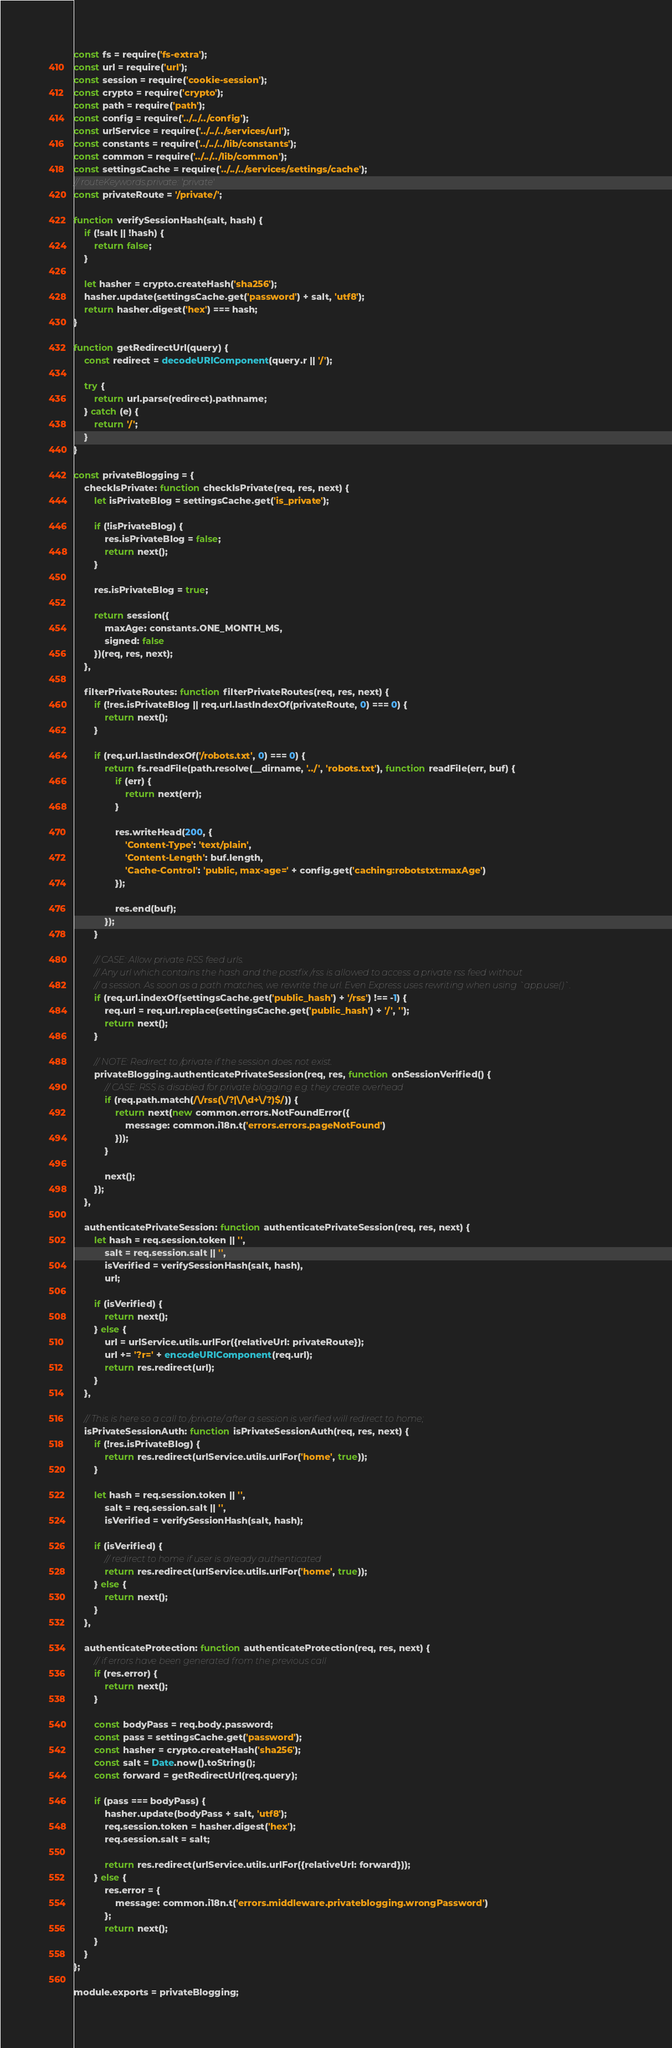<code> <loc_0><loc_0><loc_500><loc_500><_JavaScript_>const fs = require('fs-extra');
const url = require('url');
const session = require('cookie-session');
const crypto = require('crypto');
const path = require('path');
const config = require('../../../config');
const urlService = require('../../../services/url');
const constants = require('../../../lib/constants');
const common = require('../../../lib/common');
const settingsCache = require('../../../services/settings/cache');
// routeKeywords.private: 'private'
const privateRoute = '/private/';

function verifySessionHash(salt, hash) {
    if (!salt || !hash) {
        return false;
    }

    let hasher = crypto.createHash('sha256');
    hasher.update(settingsCache.get('password') + salt, 'utf8');
    return hasher.digest('hex') === hash;
}

function getRedirectUrl(query) {
    const redirect = decodeURIComponent(query.r || '/');

    try {
        return url.parse(redirect).pathname;
    } catch (e) {
        return '/';
    }
}

const privateBlogging = {
    checkIsPrivate: function checkIsPrivate(req, res, next) {
        let isPrivateBlog = settingsCache.get('is_private');

        if (!isPrivateBlog) {
            res.isPrivateBlog = false;
            return next();
        }

        res.isPrivateBlog = true;

        return session({
            maxAge: constants.ONE_MONTH_MS,
            signed: false
        })(req, res, next);
    },

    filterPrivateRoutes: function filterPrivateRoutes(req, res, next) {
        if (!res.isPrivateBlog || req.url.lastIndexOf(privateRoute, 0) === 0) {
            return next();
        }

        if (req.url.lastIndexOf('/robots.txt', 0) === 0) {
            return fs.readFile(path.resolve(__dirname, '../', 'robots.txt'), function readFile(err, buf) {
                if (err) {
                    return next(err);
                }

                res.writeHead(200, {
                    'Content-Type': 'text/plain',
                    'Content-Length': buf.length,
                    'Cache-Control': 'public, max-age=' + config.get('caching:robotstxt:maxAge')
                });

                res.end(buf);
            });
        }

        // CASE: Allow private RSS feed urls.
        // Any url which contains the hash and the postfix /rss is allowed to access a private rss feed without
        // a session. As soon as a path matches, we rewrite the url. Even Express uses rewriting when using `app.use()`.
        if (req.url.indexOf(settingsCache.get('public_hash') + '/rss') !== -1) {
            req.url = req.url.replace(settingsCache.get('public_hash') + '/', '');
            return next();
        }

        // NOTE: Redirect to /private if the session does not exist.
        privateBlogging.authenticatePrivateSession(req, res, function onSessionVerified() {
            // CASE: RSS is disabled for private blogging e.g. they create overhead
            if (req.path.match(/\/rss(\/?|\/\d+\/?)$/)) {
                return next(new common.errors.NotFoundError({
                    message: common.i18n.t('errors.errors.pageNotFound')
                }));
            }

            next();
        });
    },

    authenticatePrivateSession: function authenticatePrivateSession(req, res, next) {
        let hash = req.session.token || '',
            salt = req.session.salt || '',
            isVerified = verifySessionHash(salt, hash),
            url;

        if (isVerified) {
            return next();
        } else {
            url = urlService.utils.urlFor({relativeUrl: privateRoute});
            url += '?r=' + encodeURIComponent(req.url);
            return res.redirect(url);
        }
    },

    // This is here so a call to /private/ after a session is verified will redirect to home;
    isPrivateSessionAuth: function isPrivateSessionAuth(req, res, next) {
        if (!res.isPrivateBlog) {
            return res.redirect(urlService.utils.urlFor('home', true));
        }

        let hash = req.session.token || '',
            salt = req.session.salt || '',
            isVerified = verifySessionHash(salt, hash);

        if (isVerified) {
            // redirect to home if user is already authenticated
            return res.redirect(urlService.utils.urlFor('home', true));
        } else {
            return next();
        }
    },

    authenticateProtection: function authenticateProtection(req, res, next) {
        // if errors have been generated from the previous call
        if (res.error) {
            return next();
        }

        const bodyPass = req.body.password;
        const pass = settingsCache.get('password');
        const hasher = crypto.createHash('sha256');
        const salt = Date.now().toString();
        const forward = getRedirectUrl(req.query);

        if (pass === bodyPass) {
            hasher.update(bodyPass + salt, 'utf8');
            req.session.token = hasher.digest('hex');
            req.session.salt = salt;

            return res.redirect(urlService.utils.urlFor({relativeUrl: forward}));
        } else {
            res.error = {
                message: common.i18n.t('errors.middleware.privateblogging.wrongPassword')
            };
            return next();
        }
    }
};

module.exports = privateBlogging;
</code> 